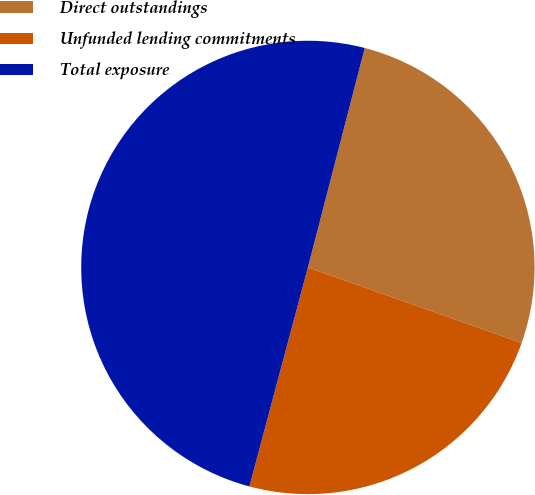Convert chart. <chart><loc_0><loc_0><loc_500><loc_500><pie_chart><fcel>Direct outstandings<fcel>Unfunded lending commitments<fcel>Total exposure<nl><fcel>26.37%<fcel>23.75%<fcel>49.88%<nl></chart> 